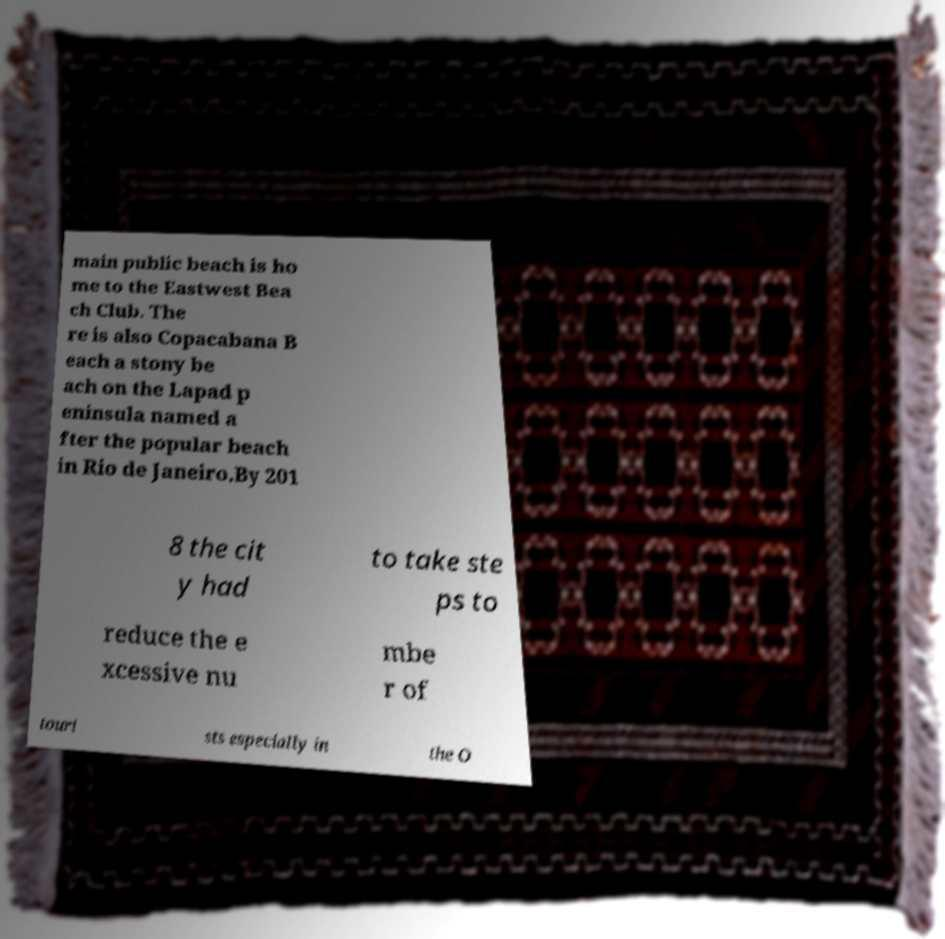There's text embedded in this image that I need extracted. Can you transcribe it verbatim? main public beach is ho me to the Eastwest Bea ch Club. The re is also Copacabana B each a stony be ach on the Lapad p eninsula named a fter the popular beach in Rio de Janeiro.By 201 8 the cit y had to take ste ps to reduce the e xcessive nu mbe r of touri sts especially in the O 